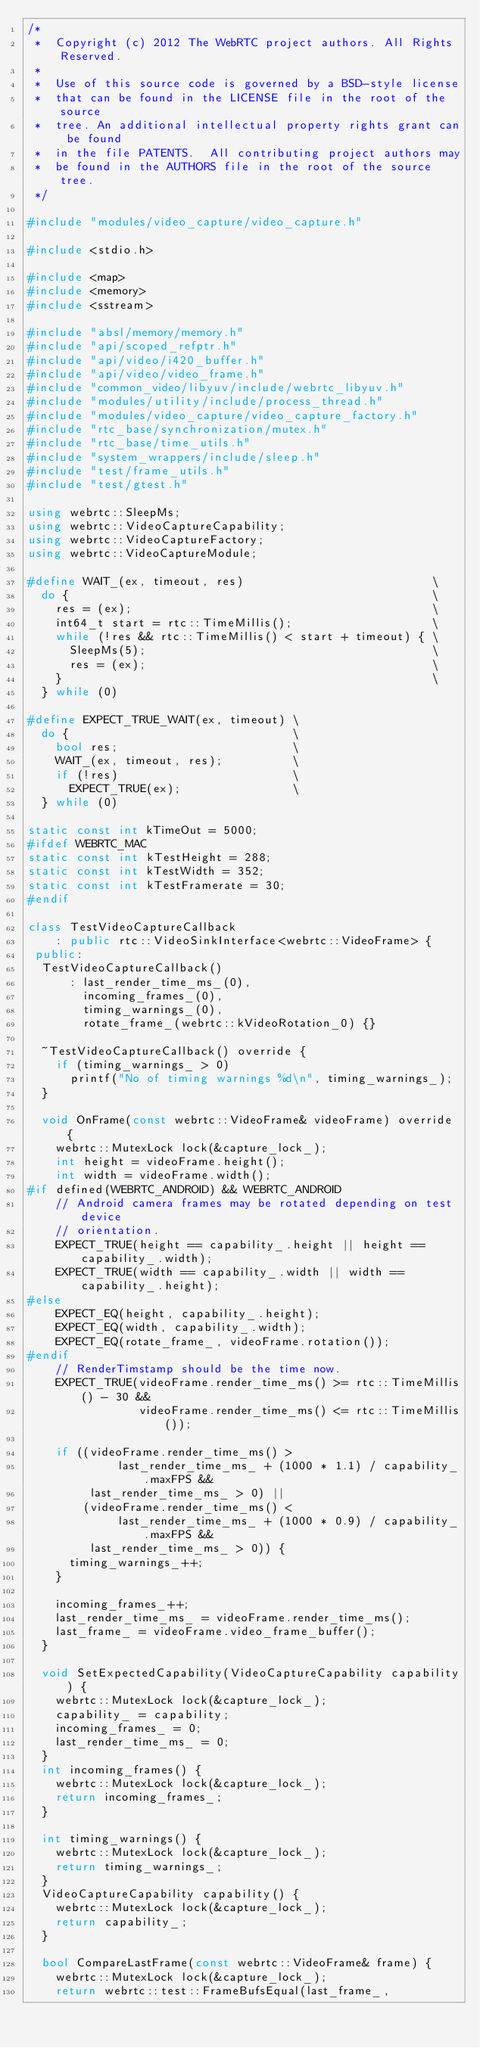Convert code to text. <code><loc_0><loc_0><loc_500><loc_500><_C++_>/*
 *  Copyright (c) 2012 The WebRTC project authors. All Rights Reserved.
 *
 *  Use of this source code is governed by a BSD-style license
 *  that can be found in the LICENSE file in the root of the source
 *  tree. An additional intellectual property rights grant can be found
 *  in the file PATENTS.  All contributing project authors may
 *  be found in the AUTHORS file in the root of the source tree.
 */

#include "modules/video_capture/video_capture.h"

#include <stdio.h>

#include <map>
#include <memory>
#include <sstream>

#include "absl/memory/memory.h"
#include "api/scoped_refptr.h"
#include "api/video/i420_buffer.h"
#include "api/video/video_frame.h"
#include "common_video/libyuv/include/webrtc_libyuv.h"
#include "modules/utility/include/process_thread.h"
#include "modules/video_capture/video_capture_factory.h"
#include "rtc_base/synchronization/mutex.h"
#include "rtc_base/time_utils.h"
#include "system_wrappers/include/sleep.h"
#include "test/frame_utils.h"
#include "test/gtest.h"

using webrtc::SleepMs;
using webrtc::VideoCaptureCapability;
using webrtc::VideoCaptureFactory;
using webrtc::VideoCaptureModule;

#define WAIT_(ex, timeout, res)                           \
  do {                                                    \
    res = (ex);                                           \
    int64_t start = rtc::TimeMillis();                    \
    while (!res && rtc::TimeMillis() < start + timeout) { \
      SleepMs(5);                                         \
      res = (ex);                                         \
    }                                                     \
  } while (0)

#define EXPECT_TRUE_WAIT(ex, timeout) \
  do {                                \
    bool res;                         \
    WAIT_(ex, timeout, res);          \
    if (!res)                         \
      EXPECT_TRUE(ex);                \
  } while (0)

static const int kTimeOut = 5000;
#ifdef WEBRTC_MAC
static const int kTestHeight = 288;
static const int kTestWidth = 352;
static const int kTestFramerate = 30;
#endif

class TestVideoCaptureCallback
    : public rtc::VideoSinkInterface<webrtc::VideoFrame> {
 public:
  TestVideoCaptureCallback()
      : last_render_time_ms_(0),
        incoming_frames_(0),
        timing_warnings_(0),
        rotate_frame_(webrtc::kVideoRotation_0) {}

  ~TestVideoCaptureCallback() override {
    if (timing_warnings_ > 0)
      printf("No of timing warnings %d\n", timing_warnings_);
  }

  void OnFrame(const webrtc::VideoFrame& videoFrame) override {
    webrtc::MutexLock lock(&capture_lock_);
    int height = videoFrame.height();
    int width = videoFrame.width();
#if defined(WEBRTC_ANDROID) && WEBRTC_ANDROID
    // Android camera frames may be rotated depending on test device
    // orientation.
    EXPECT_TRUE(height == capability_.height || height == capability_.width);
    EXPECT_TRUE(width == capability_.width || width == capability_.height);
#else
    EXPECT_EQ(height, capability_.height);
    EXPECT_EQ(width, capability_.width);
    EXPECT_EQ(rotate_frame_, videoFrame.rotation());
#endif
    // RenderTimstamp should be the time now.
    EXPECT_TRUE(videoFrame.render_time_ms() >= rtc::TimeMillis() - 30 &&
                videoFrame.render_time_ms() <= rtc::TimeMillis());

    if ((videoFrame.render_time_ms() >
             last_render_time_ms_ + (1000 * 1.1) / capability_.maxFPS &&
         last_render_time_ms_ > 0) ||
        (videoFrame.render_time_ms() <
             last_render_time_ms_ + (1000 * 0.9) / capability_.maxFPS &&
         last_render_time_ms_ > 0)) {
      timing_warnings_++;
    }

    incoming_frames_++;
    last_render_time_ms_ = videoFrame.render_time_ms();
    last_frame_ = videoFrame.video_frame_buffer();
  }

  void SetExpectedCapability(VideoCaptureCapability capability) {
    webrtc::MutexLock lock(&capture_lock_);
    capability_ = capability;
    incoming_frames_ = 0;
    last_render_time_ms_ = 0;
  }
  int incoming_frames() {
    webrtc::MutexLock lock(&capture_lock_);
    return incoming_frames_;
  }

  int timing_warnings() {
    webrtc::MutexLock lock(&capture_lock_);
    return timing_warnings_;
  }
  VideoCaptureCapability capability() {
    webrtc::MutexLock lock(&capture_lock_);
    return capability_;
  }

  bool CompareLastFrame(const webrtc::VideoFrame& frame) {
    webrtc::MutexLock lock(&capture_lock_);
    return webrtc::test::FrameBufsEqual(last_frame_,</code> 